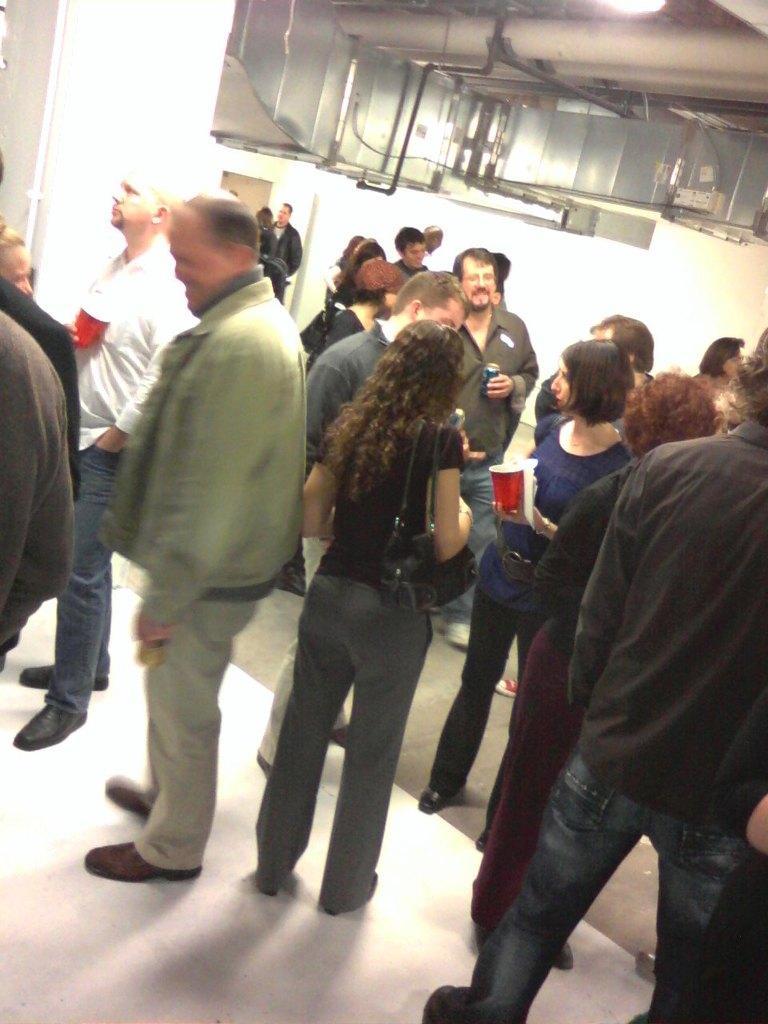Describe this image in one or two sentences. In this picture we can see a pillar, wall and objects. We can see people standing and few are holding objects. At the bottom portion of the picture we can see the floor. 